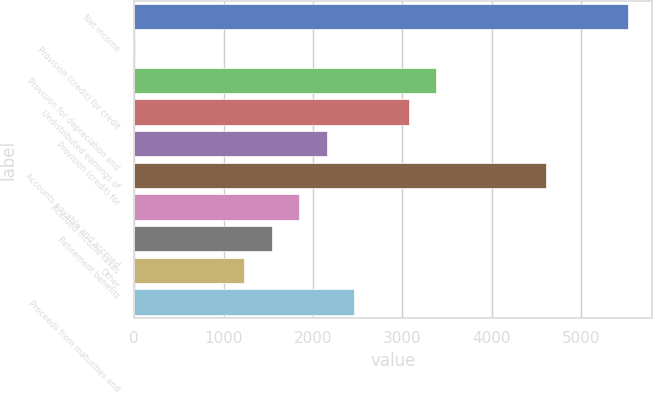<chart> <loc_0><loc_0><loc_500><loc_500><bar_chart><fcel>Net income<fcel>Provision (credit) for credit<fcel>Provision for depreciation and<fcel>Undistributed earnings of<fcel>Provision (credit) for<fcel>Accounts payable and accrued<fcel>Accrued income taxes<fcel>Retirement benefits<fcel>Other<fcel>Proceeds from maturities and<nl><fcel>5524.08<fcel>6<fcel>3378.16<fcel>3071.6<fcel>2151.92<fcel>4604.4<fcel>1845.36<fcel>1538.8<fcel>1232.24<fcel>2458.48<nl></chart> 